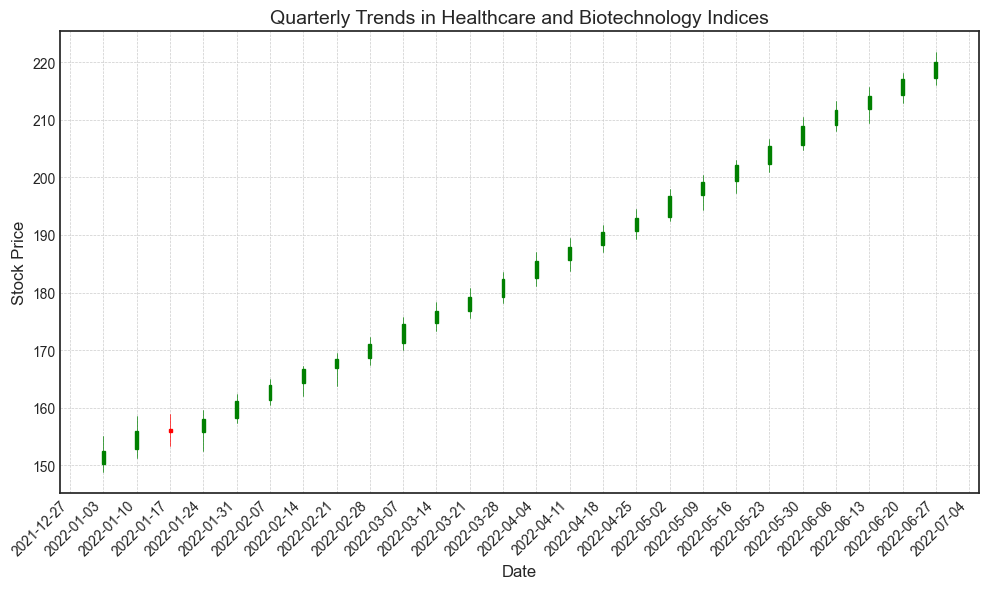Which week in January 2022 had the highest closing price? By examining the January 2022 candlesticks, we see the week of January 31 had the highest closing price of around 161.10.
Answer: January 31 What is the difference between the highest closing prices in February and March 2022? The highest closing price in February was around 171.00 on February 28, and in March, it reached around 182.40 on March 28. The difference is 182.40 - 171.00.
Answer: 11.40 How did the stock price change from the beginning to the end of Q1 2022? The stock price on January 3 was around 152.50, and on March 31, it reached around 182.40. The change is 182.40 - 152.50.
Answer: 29.90 Which month shows a consistent upward trend in the closing prices? Observing the candlesticks, March 2022 shows a consistent upward trend as the prices increased each week.
Answer: March 2022 Compare the opening price on February 7, 2022, and the closing price on February 14, 2022. Which is higher? The opening price on February 7 was around 161.25, and the closing price on February 14 was around 166.75. Thus, 166.75 is higher.
Answer: Closing price on February 14 What is the average closing price in the last three weeks of April 2022? The closing prices in the last three weeks of April are around 185.50, 188.00, and 190.50. The average is (185.50 + 188.00 + 190.50) / 3.
Answer: 188.00 Was there any week where the stock price decreased significantly between opening and closing? Observing the candlesticks, there is no week where the stock price had a significant decrease between opening and closing; it generally trends upward.
Answer: No Which quarter saw the greatest increase in stock price? Comparing the stock prices at the beginning and end of each quarter, Q2 (April to June) saw the greatest increase, starting around 182.40 and ending at around 220.00.
Answer: Q2 Estimate the percentage increase in stock price from January 3, 2022, to June 27, 2022. The price increased from 152.50 on January 3 to 220.00 on June 27. The percentage increase is ((220.00 - 152.50) / 152.50) * 100.
Answer: Approximately 44.26% In which month did the volume reach its highest point? Observing the volumes at the bottom of the candlesticks, the highest volume was in June 2022.
Answer: June 2022 